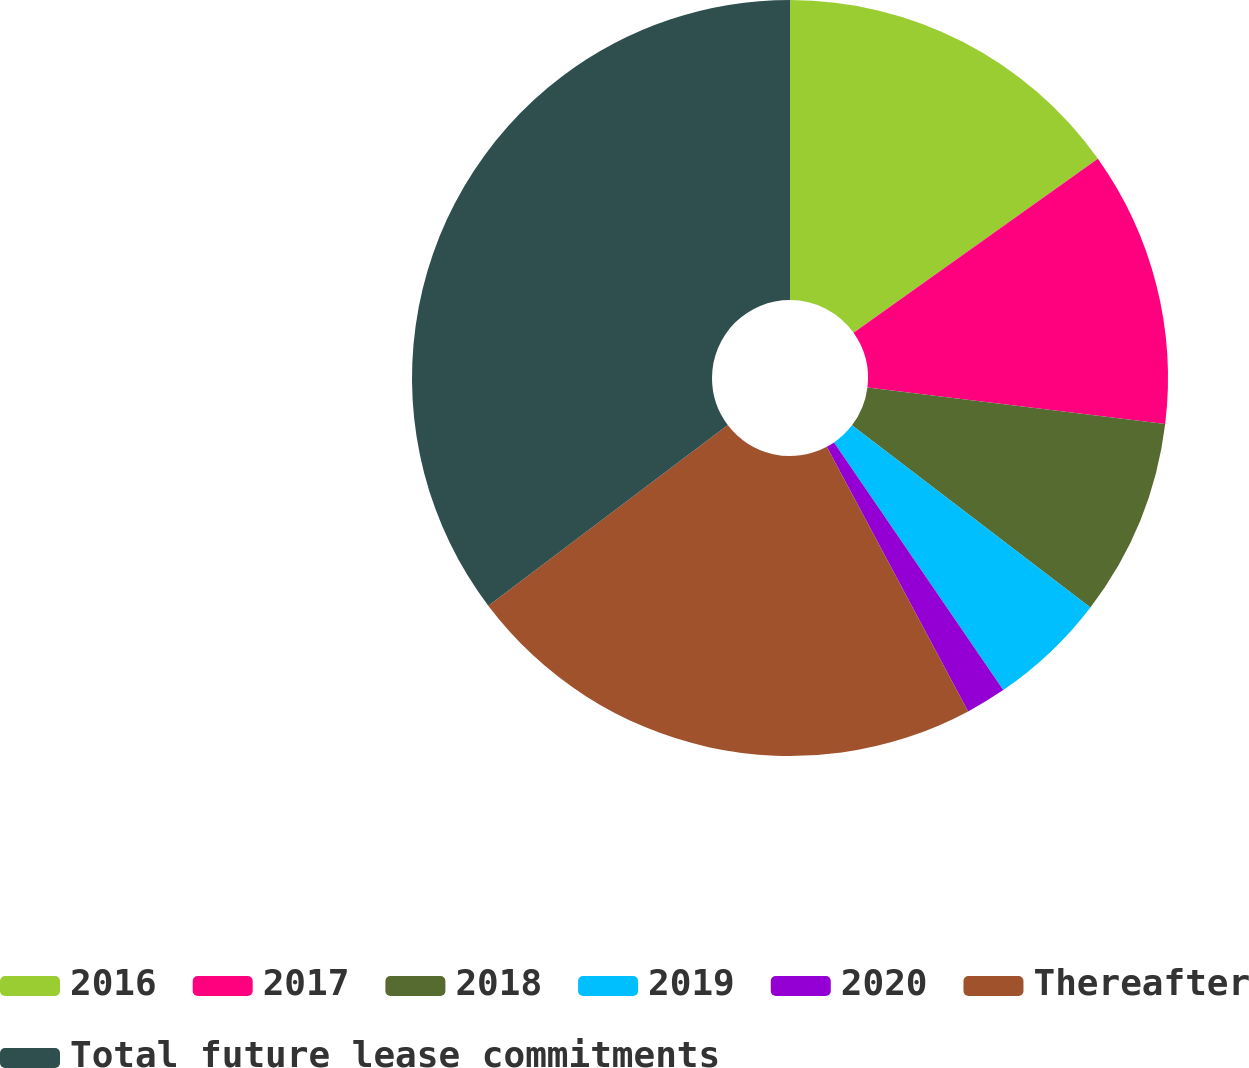<chart> <loc_0><loc_0><loc_500><loc_500><pie_chart><fcel>2016<fcel>2017<fcel>2018<fcel>2019<fcel>2020<fcel>Thereafter<fcel>Total future lease commitments<nl><fcel>15.15%<fcel>11.79%<fcel>8.44%<fcel>5.08%<fcel>1.73%<fcel>22.52%<fcel>35.29%<nl></chart> 